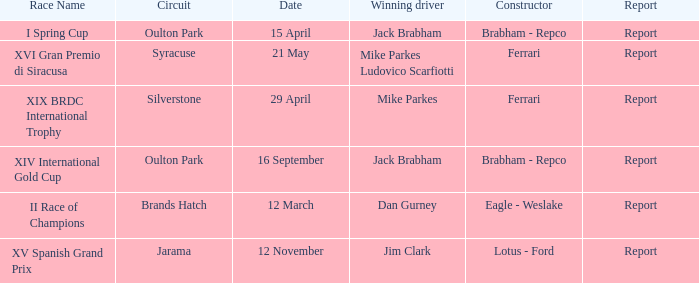What is the circuit held on 15 april? Oulton Park. 